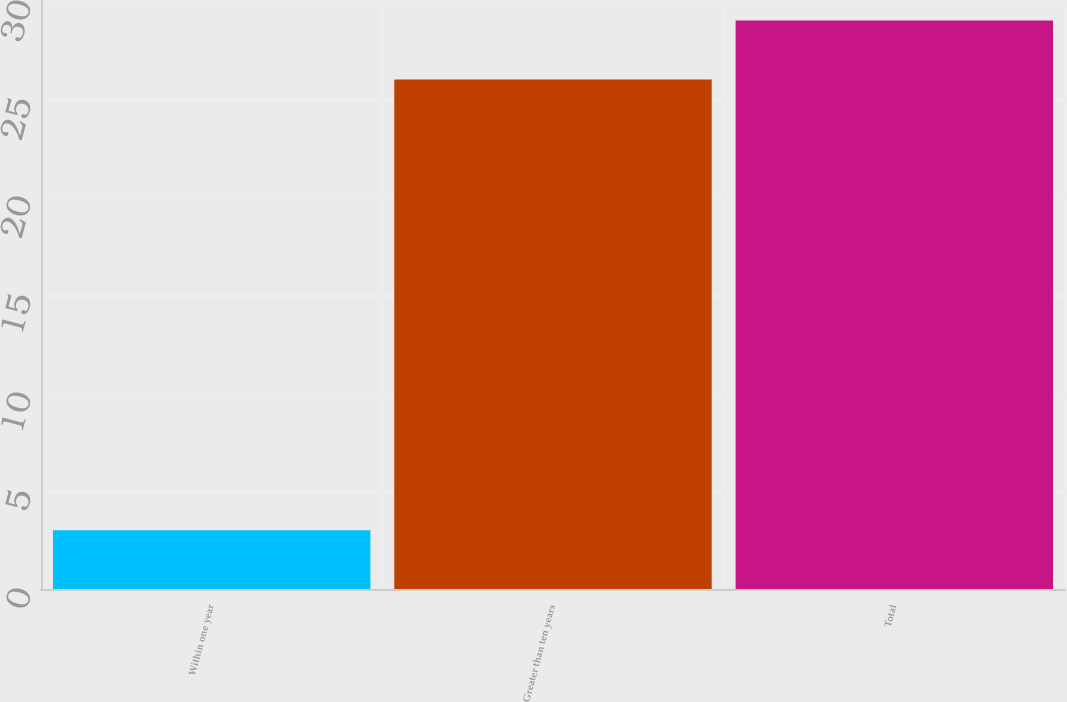Convert chart to OTSL. <chart><loc_0><loc_0><loc_500><loc_500><bar_chart><fcel>Within one year<fcel>Greater than ten years<fcel>Total<nl><fcel>3<fcel>26<fcel>29<nl></chart> 